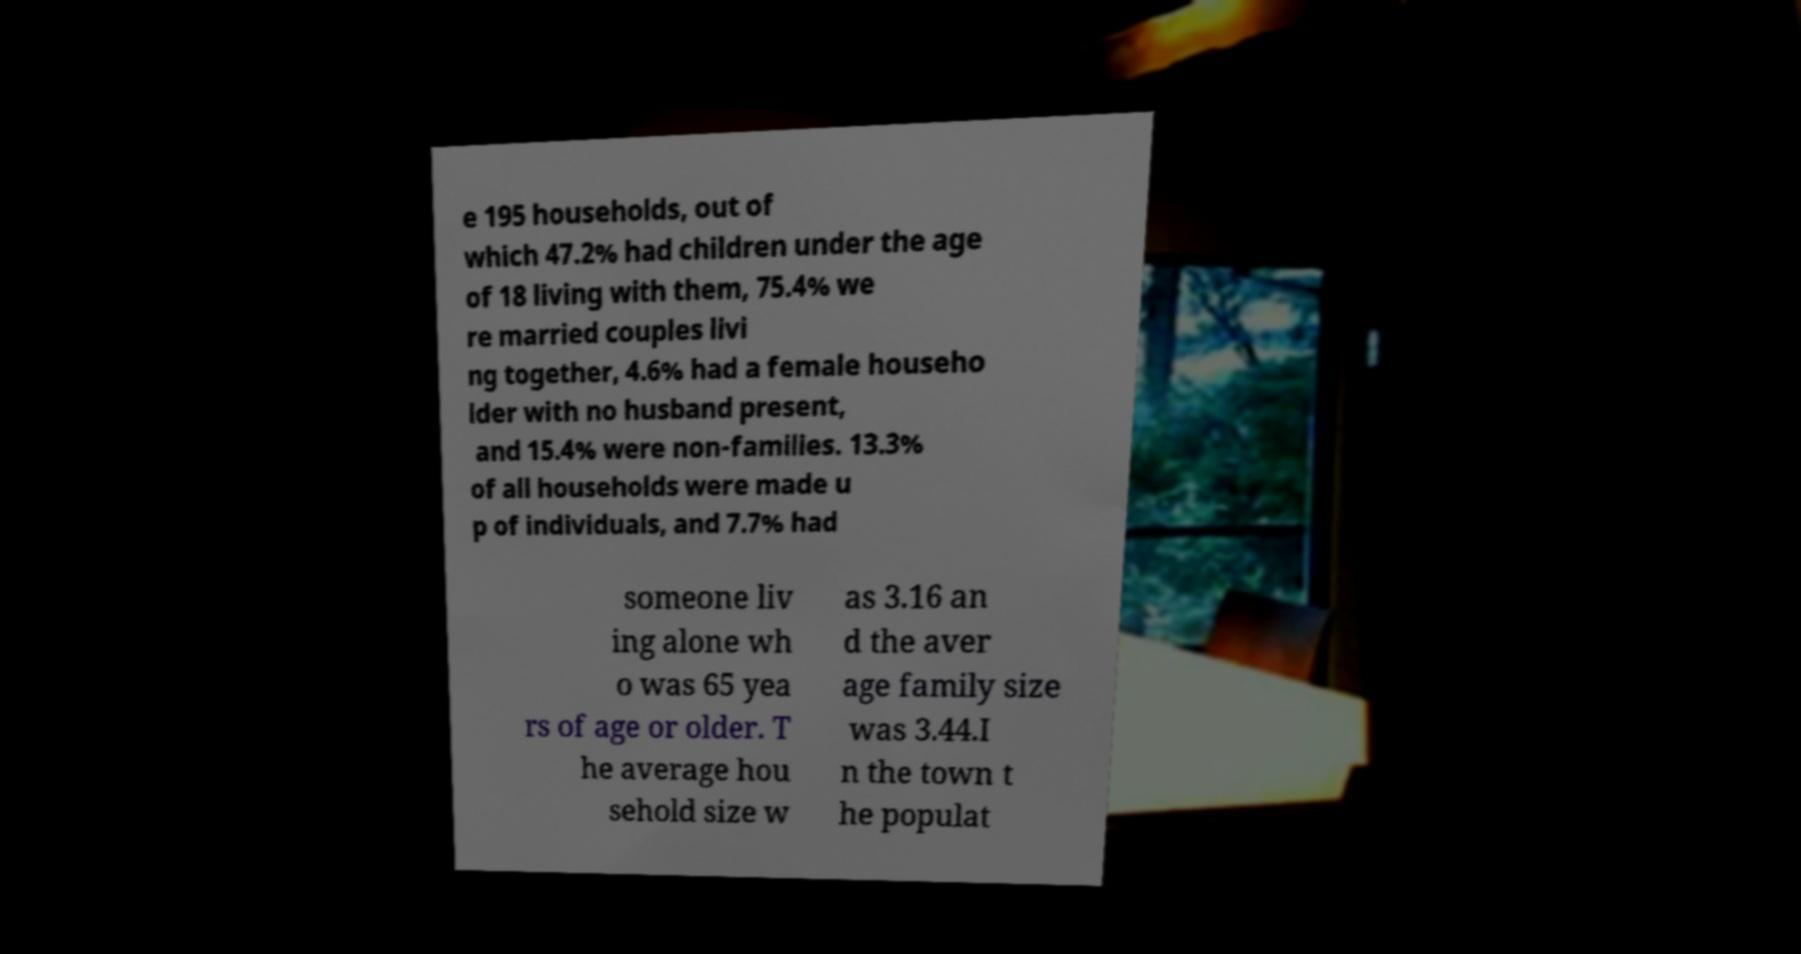Can you accurately transcribe the text from the provided image for me? e 195 households, out of which 47.2% had children under the age of 18 living with them, 75.4% we re married couples livi ng together, 4.6% had a female househo lder with no husband present, and 15.4% were non-families. 13.3% of all households were made u p of individuals, and 7.7% had someone liv ing alone wh o was 65 yea rs of age or older. T he average hou sehold size w as 3.16 an d the aver age family size was 3.44.I n the town t he populat 